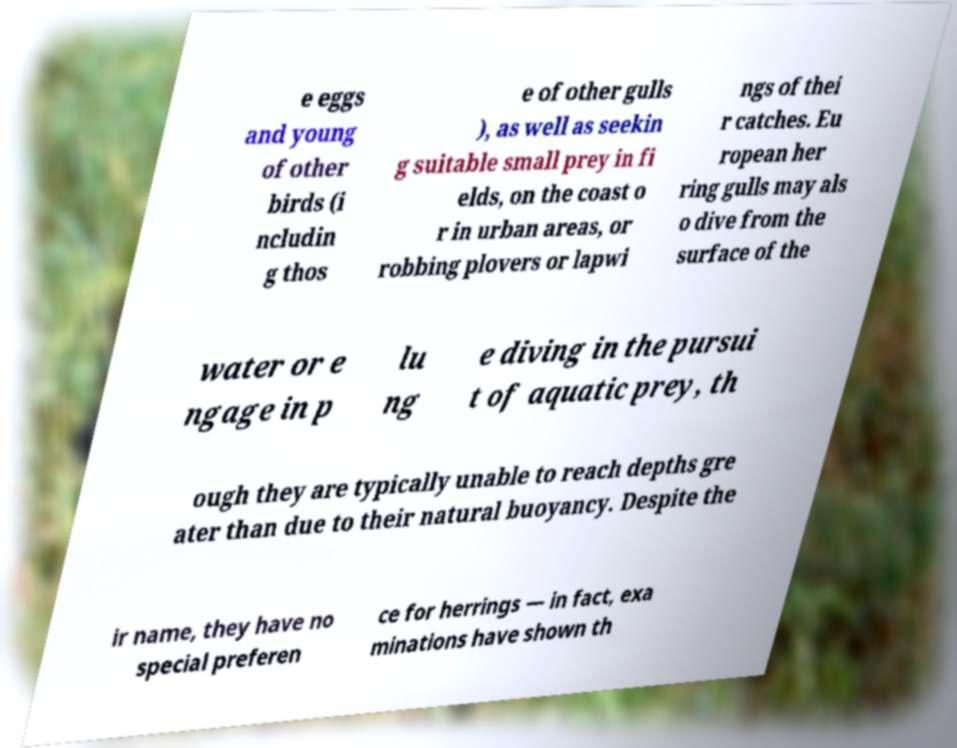What messages or text are displayed in this image? I need them in a readable, typed format. e eggs and young of other birds (i ncludin g thos e of other gulls ), as well as seekin g suitable small prey in fi elds, on the coast o r in urban areas, or robbing plovers or lapwi ngs of thei r catches. Eu ropean her ring gulls may als o dive from the surface of the water or e ngage in p lu ng e diving in the pursui t of aquatic prey, th ough they are typically unable to reach depths gre ater than due to their natural buoyancy. Despite the ir name, they have no special preferen ce for herrings — in fact, exa minations have shown th 